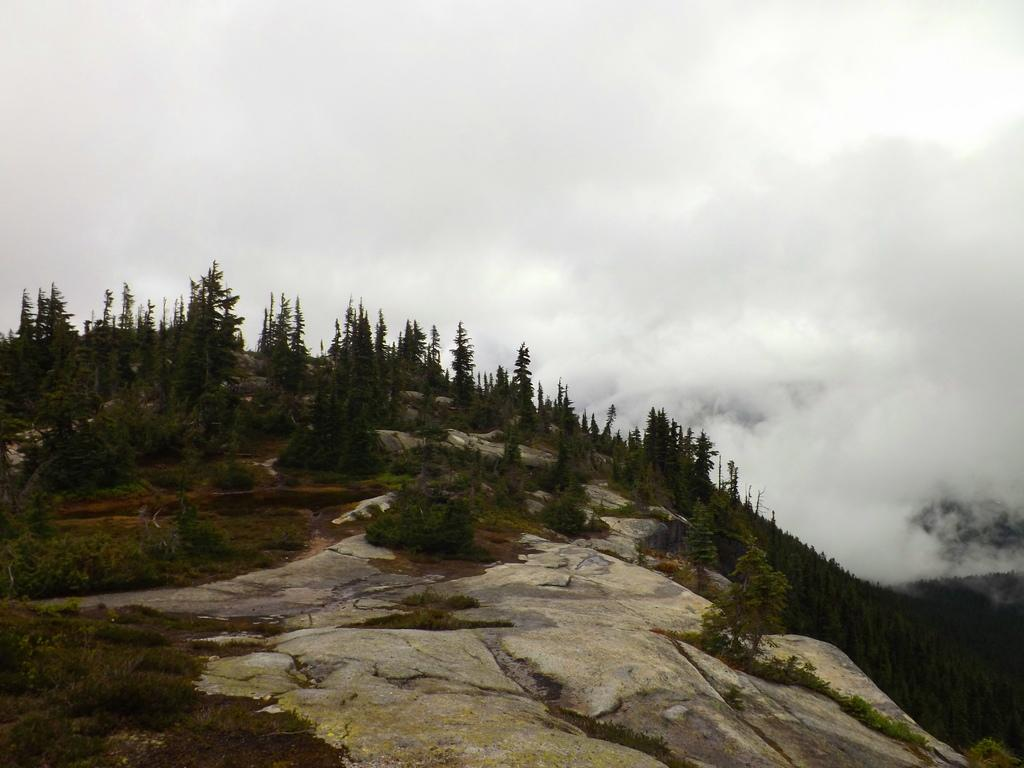What type of natural elements can be seen on the ground in the image? There are rocks, grass, and plants on the ground in the image. What type of vegetation can be seen in the background of the image? There are trees in the background of the image. What is visible in the background of the image, besides the trees? There is smoke and the sky visible in the background. What type of pets are playing in the water in the image? There are no pets or water present in the image. What news headline is visible on the newspaper in the image? There is no newspaper or news headline present in the image. 